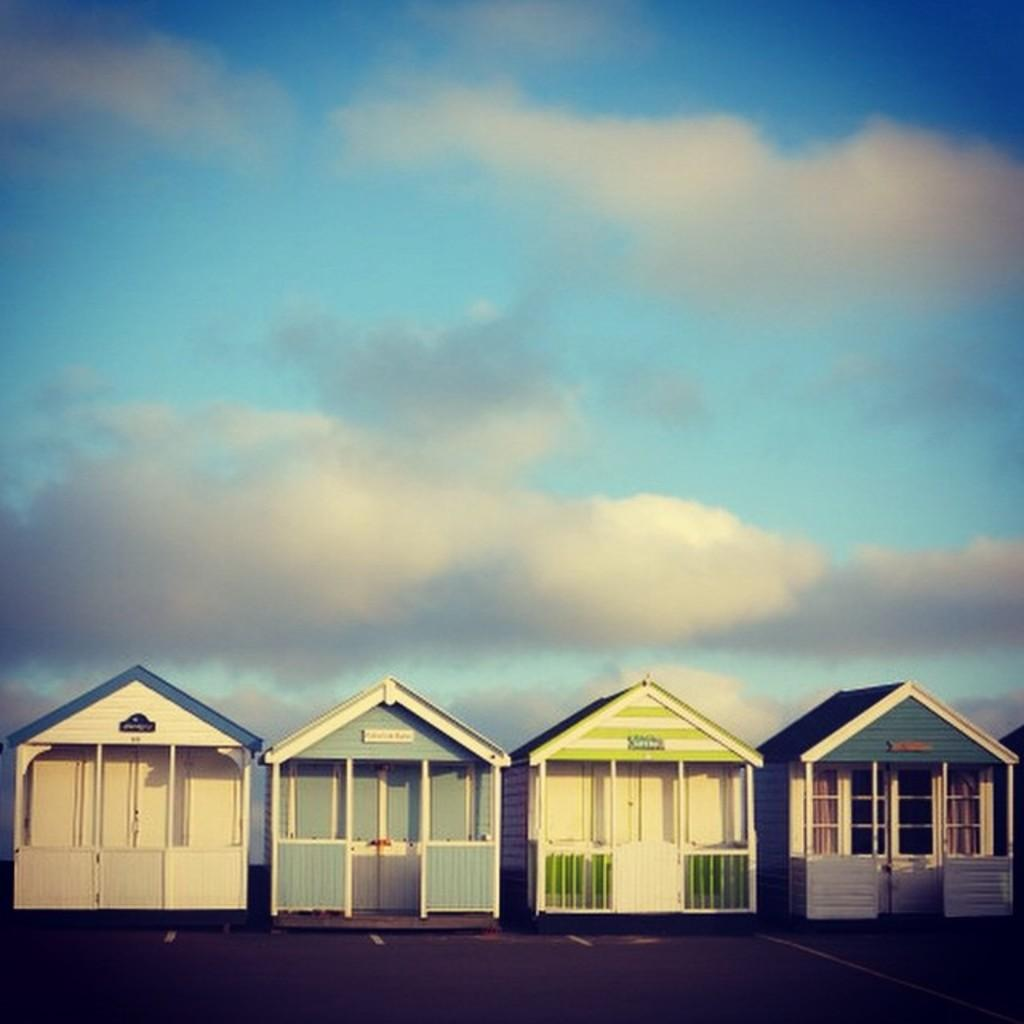How many wooden houses are in the image? There are four wooden houses in the image. What is visible at the top of the image? The sky is visible at the top of the image. What can be seen in the sky at the top of the image? There are clouds in the sky at the top of the image. What type of protest is taking place in front of the wooden houses in the image? There is no protest present in the image; it features four wooden houses and a sky with clouds. What type of cherries can be seen growing on the trees in the image? There are no cherries or trees present in the image. 